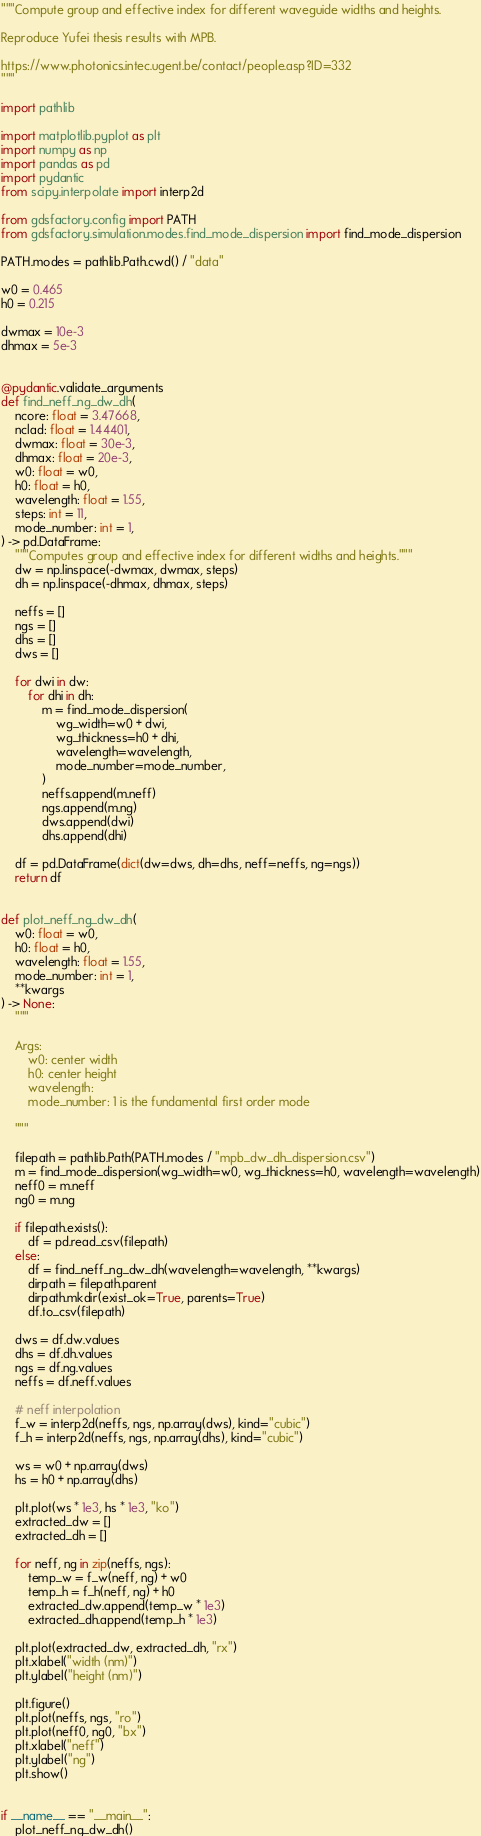<code> <loc_0><loc_0><loc_500><loc_500><_Python_>"""Compute group and effective index for different waveguide widths and heights.

Reproduce Yufei thesis results with MPB.

https://www.photonics.intec.ugent.be/contact/people.asp?ID=332
"""

import pathlib

import matplotlib.pyplot as plt
import numpy as np
import pandas as pd
import pydantic
from scipy.interpolate import interp2d

from gdsfactory.config import PATH
from gdsfactory.simulation.modes.find_mode_dispersion import find_mode_dispersion

PATH.modes = pathlib.Path.cwd() / "data"

w0 = 0.465
h0 = 0.215

dwmax = 10e-3
dhmax = 5e-3


@pydantic.validate_arguments
def find_neff_ng_dw_dh(
    ncore: float = 3.47668,
    nclad: float = 1.44401,
    dwmax: float = 30e-3,
    dhmax: float = 20e-3,
    w0: float = w0,
    h0: float = h0,
    wavelength: float = 1.55,
    steps: int = 11,
    mode_number: int = 1,
) -> pd.DataFrame:
    """Computes group and effective index for different widths and heights."""
    dw = np.linspace(-dwmax, dwmax, steps)
    dh = np.linspace(-dhmax, dhmax, steps)

    neffs = []
    ngs = []
    dhs = []
    dws = []

    for dwi in dw:
        for dhi in dh:
            m = find_mode_dispersion(
                wg_width=w0 + dwi,
                wg_thickness=h0 + dhi,
                wavelength=wavelength,
                mode_number=mode_number,
            )
            neffs.append(m.neff)
            ngs.append(m.ng)
            dws.append(dwi)
            dhs.append(dhi)

    df = pd.DataFrame(dict(dw=dws, dh=dhs, neff=neffs, ng=ngs))
    return df


def plot_neff_ng_dw_dh(
    w0: float = w0,
    h0: float = h0,
    wavelength: float = 1.55,
    mode_number: int = 1,
    **kwargs
) -> None:
    """

    Args:
        w0: center width
        h0: center height
        wavelength:
        mode_number: 1 is the fundamental first order mode

    """

    filepath = pathlib.Path(PATH.modes / "mpb_dw_dh_dispersion.csv")
    m = find_mode_dispersion(wg_width=w0, wg_thickness=h0, wavelength=wavelength)
    neff0 = m.neff
    ng0 = m.ng

    if filepath.exists():
        df = pd.read_csv(filepath)
    else:
        df = find_neff_ng_dw_dh(wavelength=wavelength, **kwargs)
        dirpath = filepath.parent
        dirpath.mkdir(exist_ok=True, parents=True)
        df.to_csv(filepath)

    dws = df.dw.values
    dhs = df.dh.values
    ngs = df.ng.values
    neffs = df.neff.values

    # neff interpolation
    f_w = interp2d(neffs, ngs, np.array(dws), kind="cubic")
    f_h = interp2d(neffs, ngs, np.array(dhs), kind="cubic")

    ws = w0 + np.array(dws)
    hs = h0 + np.array(dhs)

    plt.plot(ws * 1e3, hs * 1e3, "ko")
    extracted_dw = []
    extracted_dh = []

    for neff, ng in zip(neffs, ngs):
        temp_w = f_w(neff, ng) + w0
        temp_h = f_h(neff, ng) + h0
        extracted_dw.append(temp_w * 1e3)
        extracted_dh.append(temp_h * 1e3)

    plt.plot(extracted_dw, extracted_dh, "rx")
    plt.xlabel("width (nm)")
    plt.ylabel("height (nm)")

    plt.figure()
    plt.plot(neffs, ngs, "ro")
    plt.plot(neff0, ng0, "bx")
    plt.xlabel("neff")
    plt.ylabel("ng")
    plt.show()


if __name__ == "__main__":
    plot_neff_ng_dw_dh()
</code> 